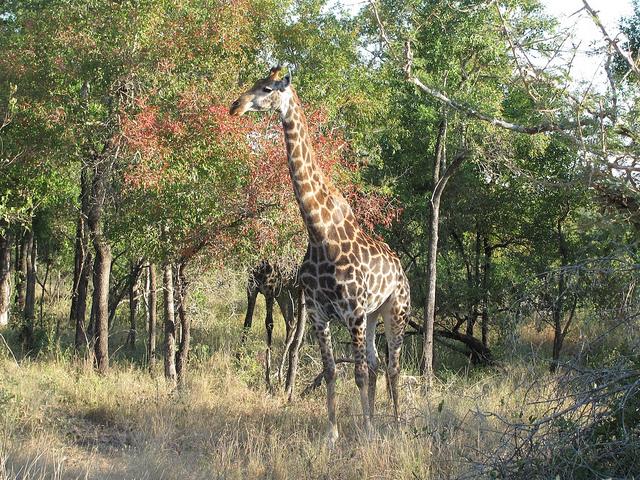What color are the leaves?
Answer briefly. Green. Are the animals in the wild?
Short answer required. Yes. How many giraffes are in the picture?
Give a very brief answer. 2. How many giraffe are in the forest?
Write a very short answer. 2. What type of trees are in the background?
Be succinct. Oak. What continent is this in?
Short answer required. Africa. Can you see the head of both giraffe?
Quick response, please. No. 